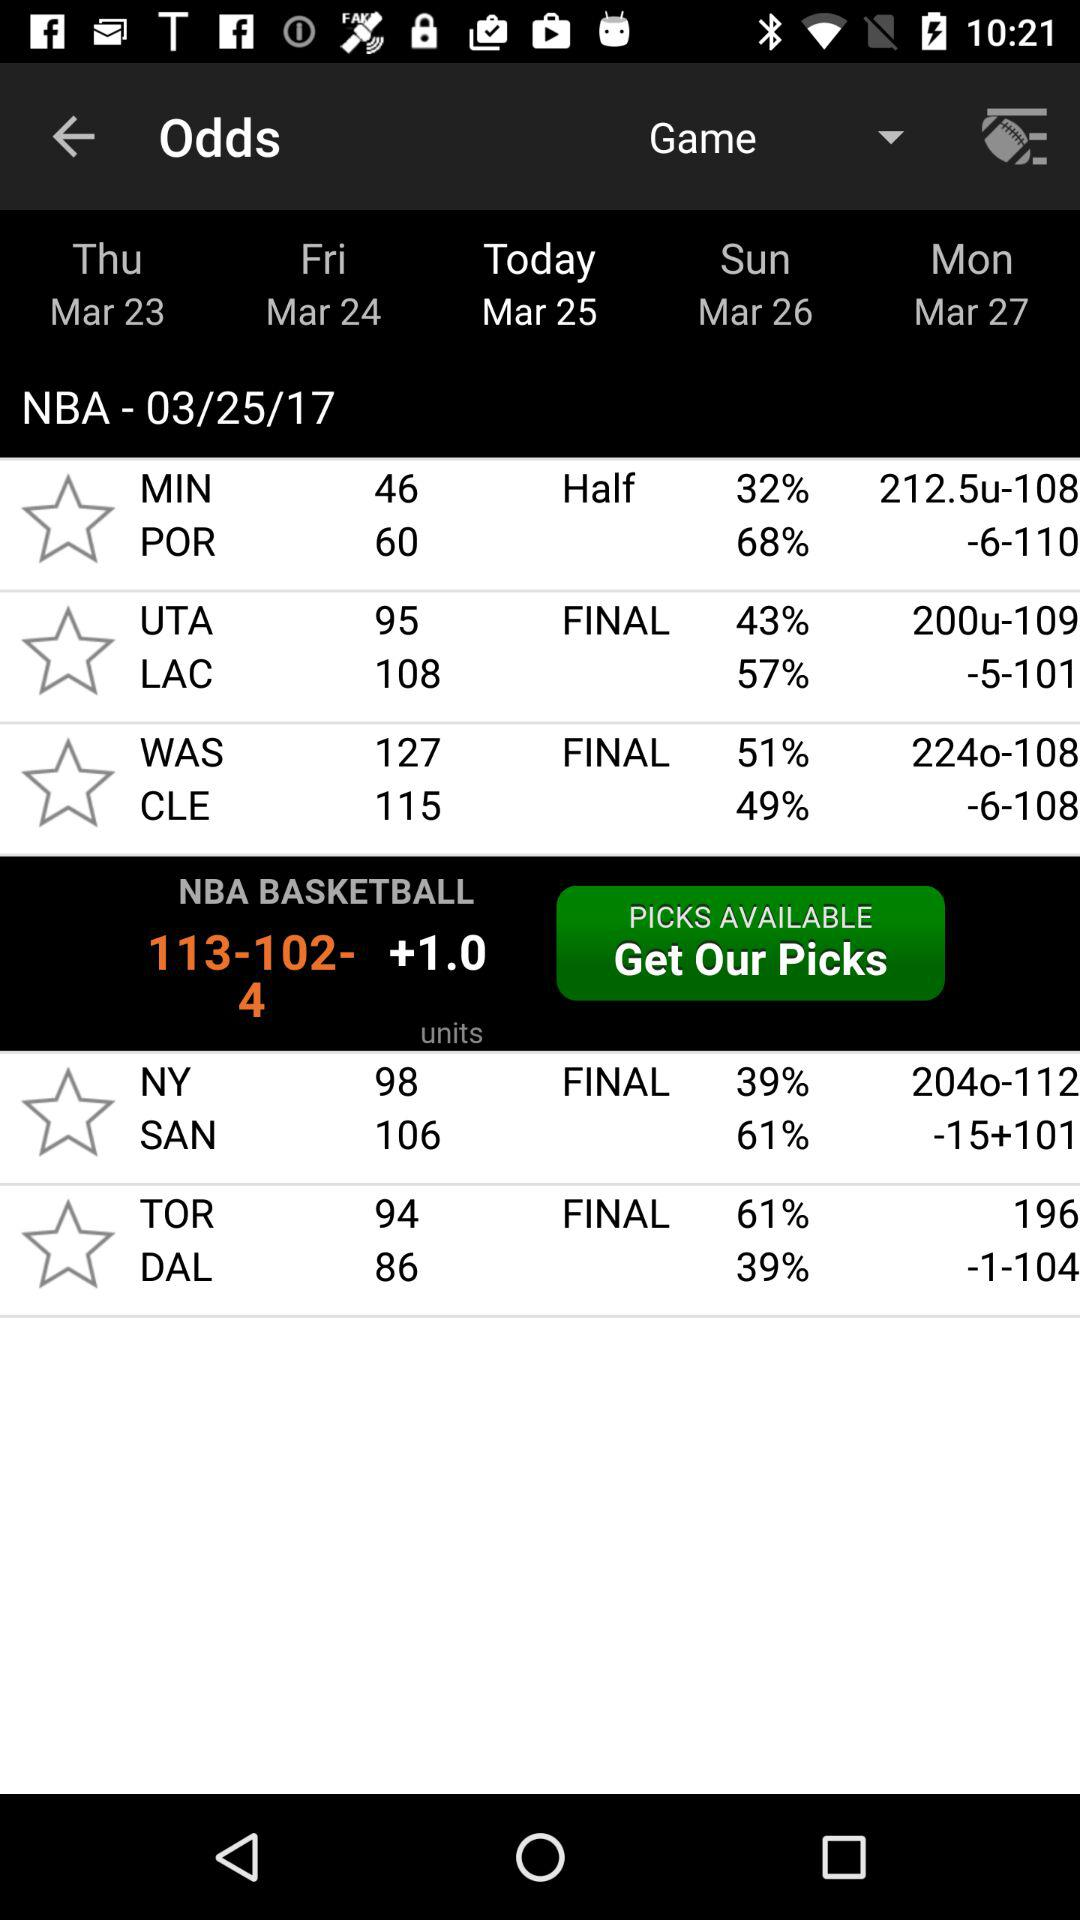What is the score of the match between MIN and POR? The scores are MIN: 46 and POR: 60. 